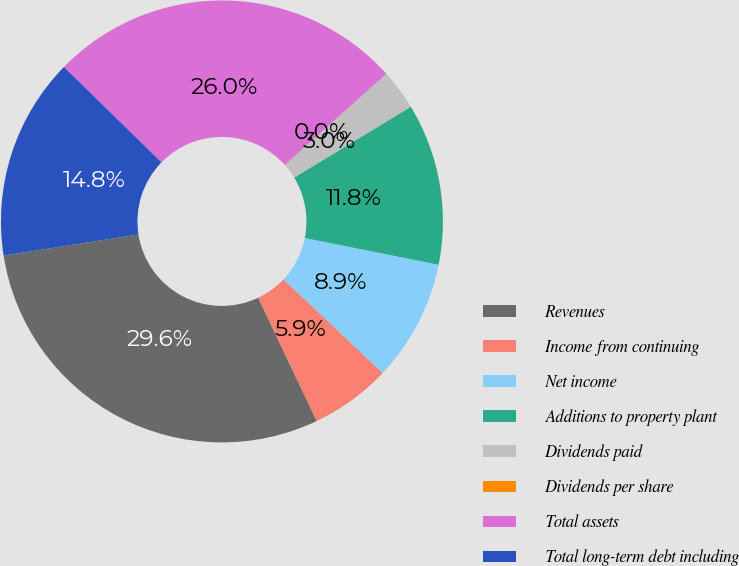<chart> <loc_0><loc_0><loc_500><loc_500><pie_chart><fcel>Revenues<fcel>Income from continuing<fcel>Net income<fcel>Additions to property plant<fcel>Dividends paid<fcel>Dividends per share<fcel>Total assets<fcel>Total long-term debt including<nl><fcel>29.59%<fcel>5.92%<fcel>8.88%<fcel>11.83%<fcel>2.96%<fcel>0.0%<fcel>26.03%<fcel>14.79%<nl></chart> 